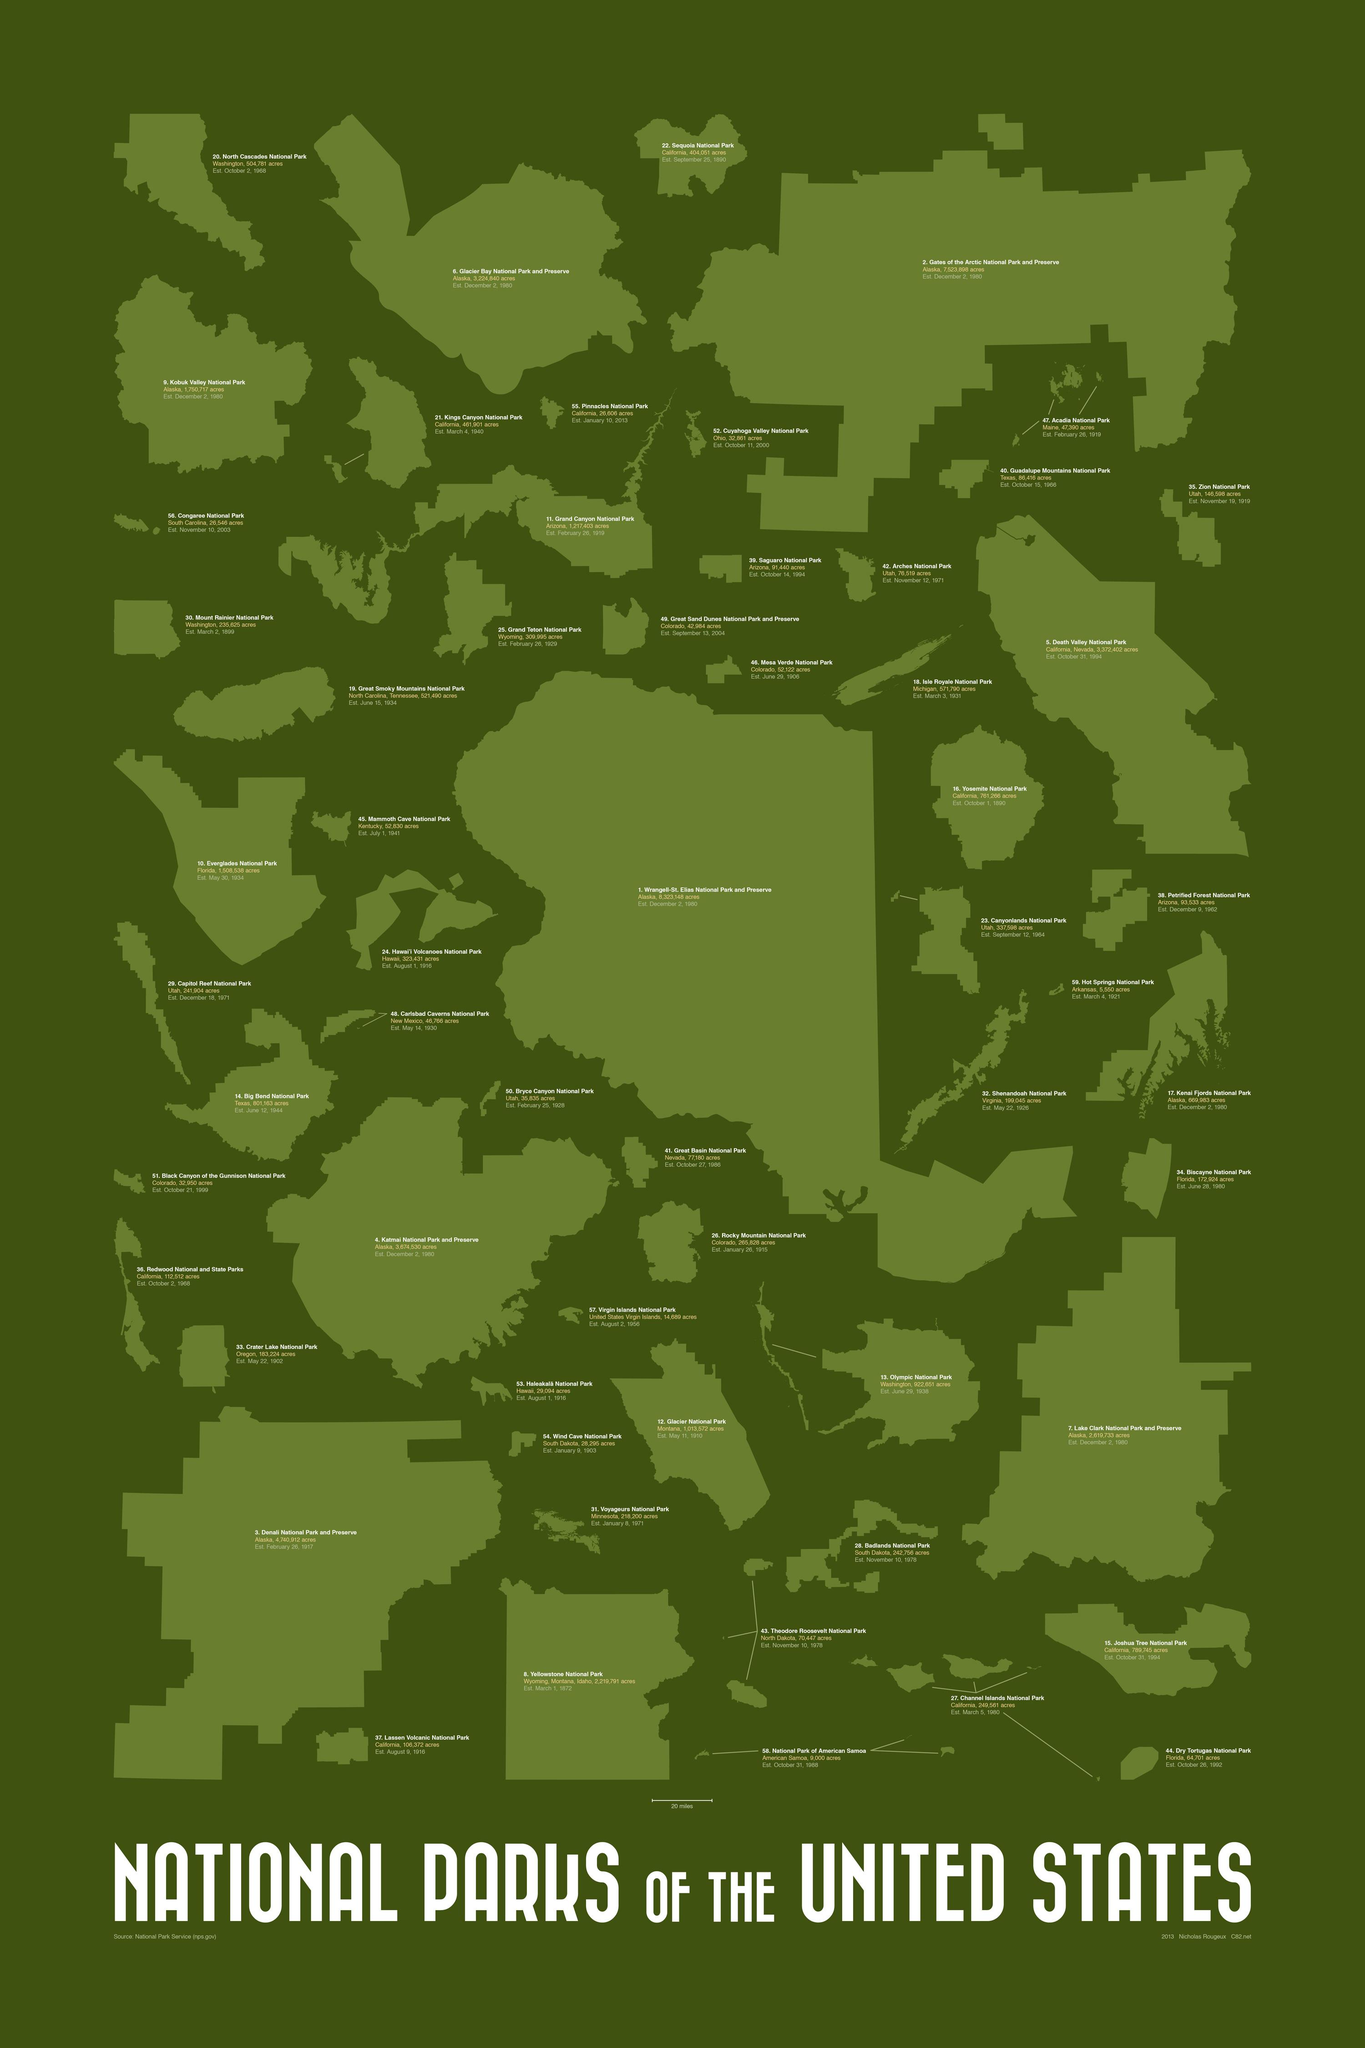Draw attention to some important aspects in this diagram. On August 9, 1916, Lassen Volcanic National Park was established, becoming a beloved and protected national treasure for all to enjoy. Grand Teton National Park was established on February 26, 1929. Death Valley National Park was established on October 31, 1994. Rocky Mountain National Park is located in the state of Colorado. The Katmai National Park and Reserve covers an area of approximately 3,674,530 acres. 